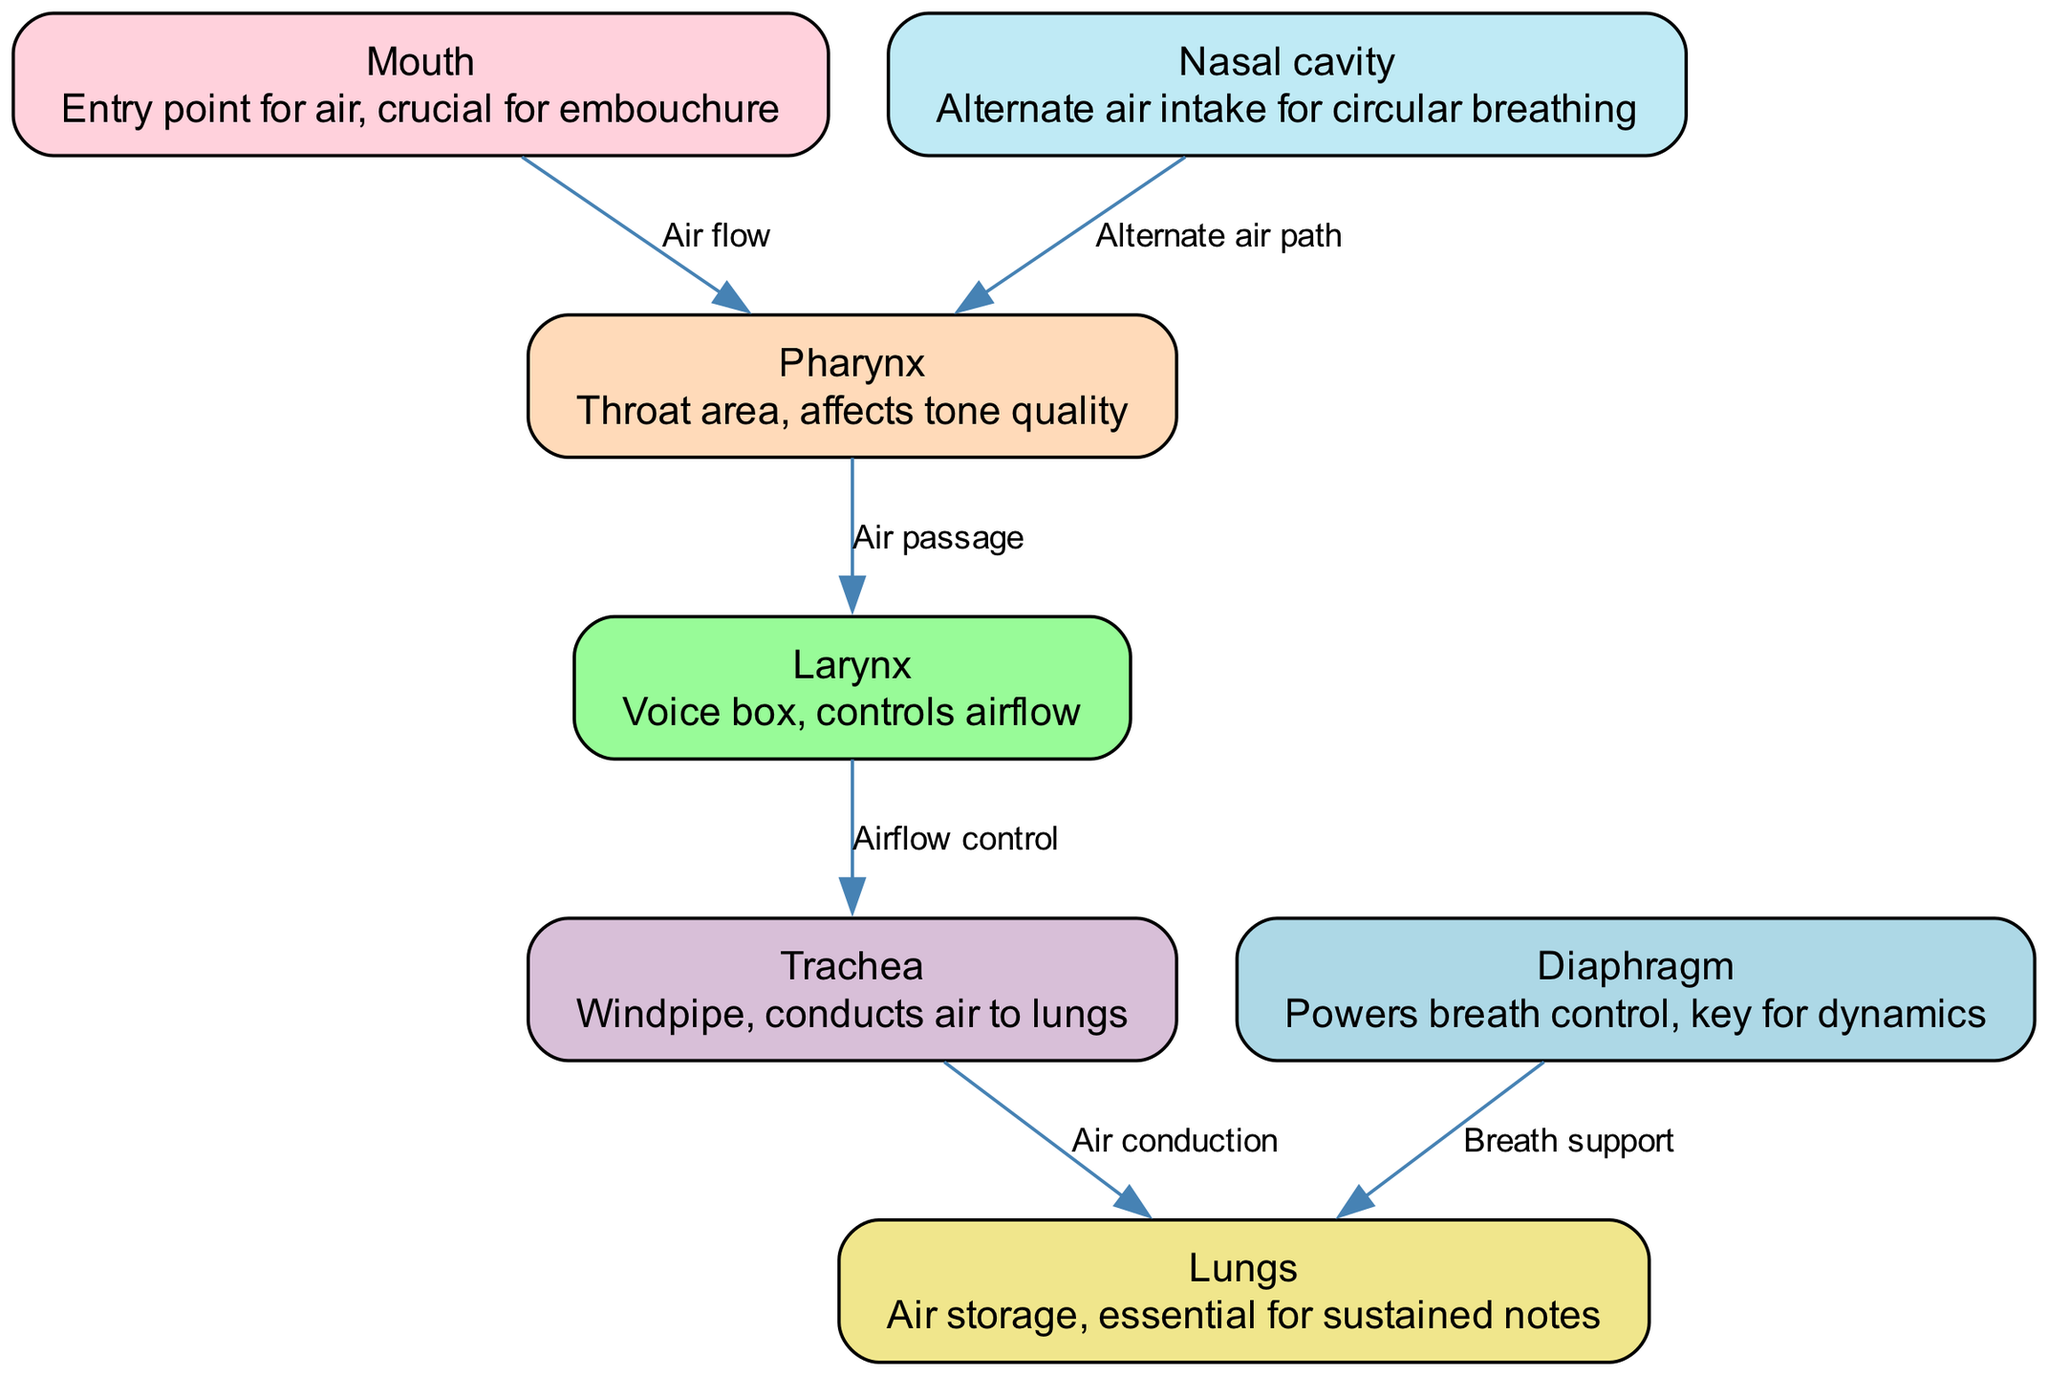What is the main entry point for air in trumpet playing? The diagram indicates the "Mouth" as the main entry point for air crucial for embouchure, making it essential for trumpet playing.
Answer: Mouth How many nodes are present in the diagram? By counting the nodes listed (Mouth, Nasal cavity, Pharynx, Larynx, Trachea, Lungs, Diaphragm), we find there are a total of 7 nodes, each representing a part of the respiratory system.
Answer: 7 What is the role of the diaphragm according to the diagram? The diagram describes the diaphragm as a part that powers breath control and is key for dynamics in trumpet playing, indicating its importance in managing airflow and pressure.
Answer: Powers breath control Which two nodes are connected by the label "Air passage"? "Air passage" connects the Pharynx and Larynx according to the edges listed in the diagram, demonstrating the flow of air through these structures.
Answer: Pharynx and Larynx What does the "Trachea" do in the respiratory process? The "Trachea," labeled as the windpipe, conducts air to the lungs, as described in the diagram, which is vital for respiration and playing sustained notes on the trumpet.
Answer: Conducts air to lungs Which parts of the respiratory system are involved in sustained notes? The diagram highlights the "Lungs" as the essential air storage area for sustained notes, directly indicating their role in maintaining airflow while playing.
Answer: Lungs What is the alternate air intake for circular breathing? According to the diagram, the "Nasal cavity" serves as the alternate air intake, allowing for circular breathing techniques that are beneficial for trumpet players.
Answer: Nasal cavity How does airflow control relate to the larynx and trachea? The diagram shows that the Larynx controls airflow, and when air moves from the Larynx to the Trachea, it is effectively managed for proper sound production and breathing techniques in trumpet playing.
Answer: Manages airflow What edge connects the diaphragm to the lungs? The edge labeled "Breath support" connects the Diaphragm to the Lungs, showing that the diaphragm plays a role in providing the necessary support for breathing while playing the trumpet.
Answer: Breath support 